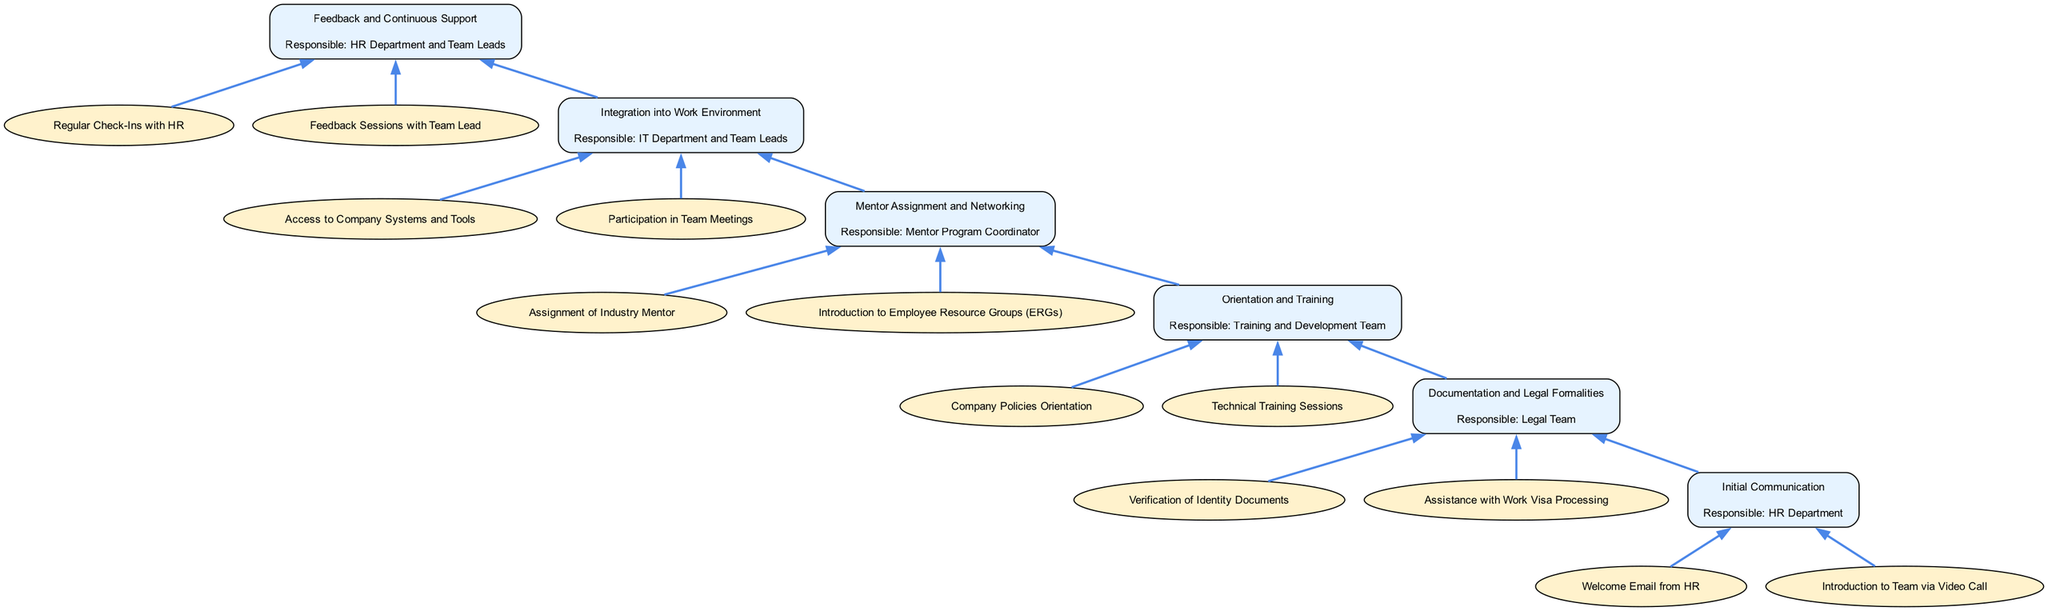What is the first stage of the onboarding process? The first stage in the diagram is labeled "Initial Communication." It is located at the bottom of the flowchart, which lists the stages in a bottom-to-top order.
Answer: Initial Communication How many activities are listed under the "Integration into Work Environment" stage? The "Integration into Work Environment" stage has two activities: "Access to Company Systems and Tools" and "Participation in Team Meetings." Therefore, the count is derived from the activities listed under that stage.
Answer: 2 What is the responsible party for the "Orientation and Training" stage? By examining the "Orientation and Training" stage in the flowchart, it specifies that the responsible party is the "Training and Development Team." Thus, locating the stage confirms this information.
Answer: Training and Development Team What stage comes before "Mentor Assignment and Networking"? To find the preceding stage, we look at the flow of the diagram. "Mentor Assignment and Networking" is stage four, the stage before it is number three, which is "Orientation and Training."
Answer: Orientation and Training In which stage is the legal team involved? The legal team is involved in the "Documentation and Legal Formalities" stage, as indicated in the diagram. It clearly assigns the legal team to this specific stage, making it straightforward.
Answer: Documentation and Legal Formalities How many total stages are included in the onboarding process? The flowchart outlines six defined stages, starting from "Initial Communication" at the bottom to "Feedback and Continuous Support" at the top. By counting each stage presented in the diagram, we confirm the total.
Answer: 6 What stage is directly responsible for the regular check-ins? The "Feedback and Continuous Support" stage is directly responsible for regular check-ins, as stated in its activities and responsible parties. This makes it clear that this stage includes those practices.
Answer: Feedback and Continuous Support What type of activities are present in the "Initial Communication" stage? The "Initial Communication" stage includes two activities: "Welcome Email from HR" and "Introduction to Team via Video Call." Both activities are clearly indicated as part of this stage in the diagram.
Answer: Welcome Email from HR, Introduction to Team via Video Call What is the last stage in the onboarding process? The last stage in the diagram is "Feedback and Continuous Support," which is positioned at the top of the flowchart. This position signifies that it is the concluding stage in the onboarding process.
Answer: Feedback and Continuous Support 